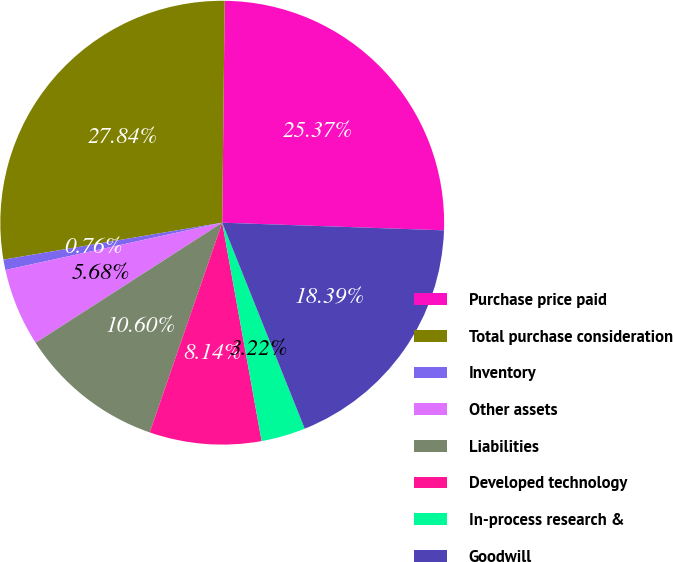Convert chart. <chart><loc_0><loc_0><loc_500><loc_500><pie_chart><fcel>Purchase price paid<fcel>Total purchase consideration<fcel>Inventory<fcel>Other assets<fcel>Liabilities<fcel>Developed technology<fcel>In-process research &<fcel>Goodwill<nl><fcel>25.37%<fcel>27.84%<fcel>0.76%<fcel>5.68%<fcel>10.6%<fcel>8.14%<fcel>3.22%<fcel>18.39%<nl></chart> 